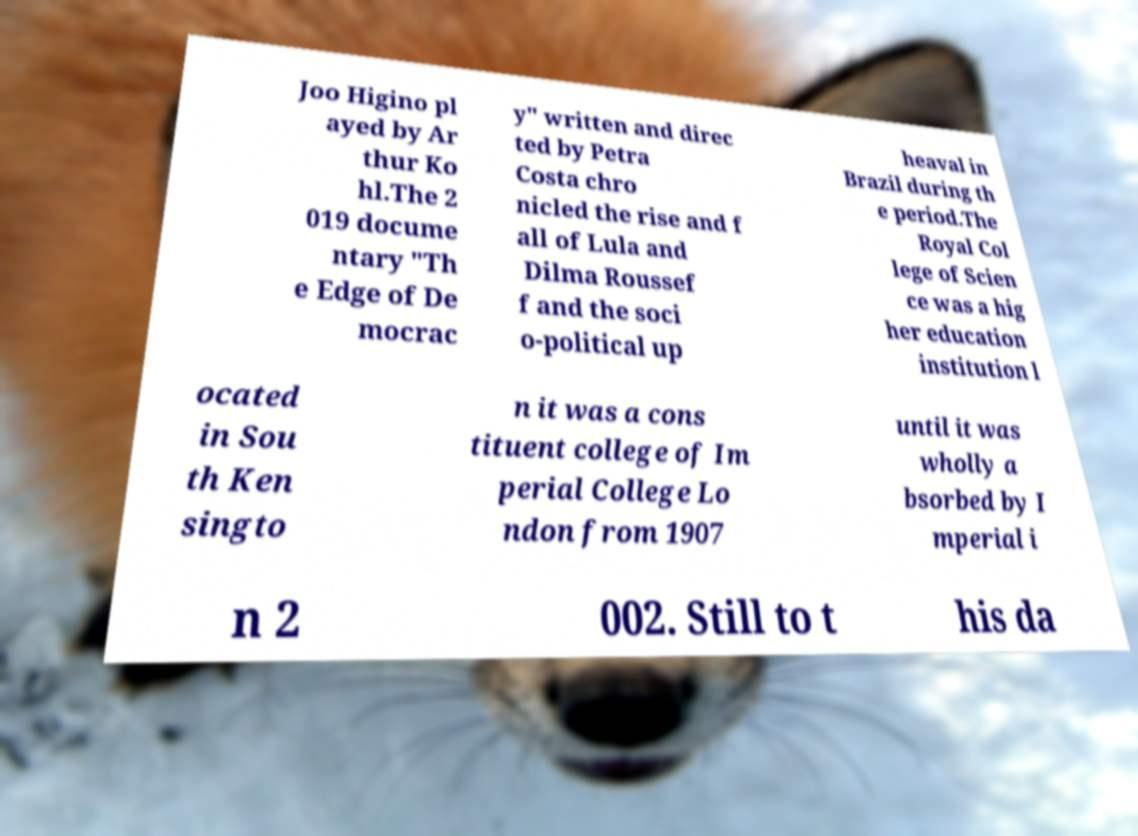What messages or text are displayed in this image? I need them in a readable, typed format. Joo Higino pl ayed by Ar thur Ko hl.The 2 019 docume ntary "Th e Edge of De mocrac y" written and direc ted by Petra Costa chro nicled the rise and f all of Lula and Dilma Roussef f and the soci o-political up heaval in Brazil during th e period.The Royal Col lege of Scien ce was a hig her education institution l ocated in Sou th Ken singto n it was a cons tituent college of Im perial College Lo ndon from 1907 until it was wholly a bsorbed by I mperial i n 2 002. Still to t his da 